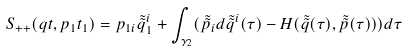Convert formula to latex. <formula><loc_0><loc_0><loc_500><loc_500>S _ { + + } ( q t , p _ { 1 } t _ { 1 } ) = p _ { 1 i } \tilde { \tilde { q } } _ { 1 } ^ { i } + \int _ { \gamma _ { 2 } } ( \tilde { \tilde { p } } _ { i } d \tilde { \tilde { q } } ^ { i } ( \tau ) - H ( \tilde { \tilde { q } } ( \tau ) , \tilde { \tilde { p } } ( \tau ) ) ) d \tau</formula> 